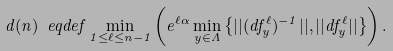Convert formula to latex. <formula><loc_0><loc_0><loc_500><loc_500>d ( n ) \ e q d e f \min _ { 1 \leq \ell \leq n - 1 } \left ( e ^ { \ell \alpha } \min _ { y \in \Lambda } \left \{ | | ( d f _ { y } ^ { \ell } ) ^ { - 1 } | | , | | d f _ { y } ^ { \ell } | | \right \} \right ) .</formula> 